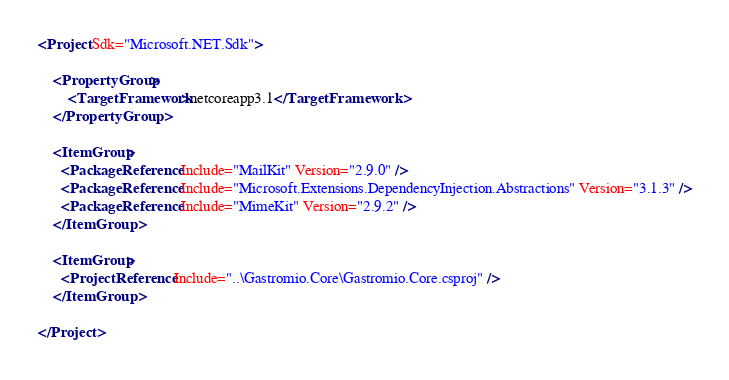Convert code to text. <code><loc_0><loc_0><loc_500><loc_500><_XML_><Project Sdk="Microsoft.NET.Sdk">

    <PropertyGroup>
        <TargetFramework>netcoreapp3.1</TargetFramework>
    </PropertyGroup>

    <ItemGroup>
      <PackageReference Include="MailKit" Version="2.9.0" />
      <PackageReference Include="Microsoft.Extensions.DependencyInjection.Abstractions" Version="3.1.3" />
      <PackageReference Include="MimeKit" Version="2.9.2" />
    </ItemGroup>

    <ItemGroup>
      <ProjectReference Include="..\Gastromio.Core\Gastromio.Core.csproj" />
    </ItemGroup>

</Project>
</code> 